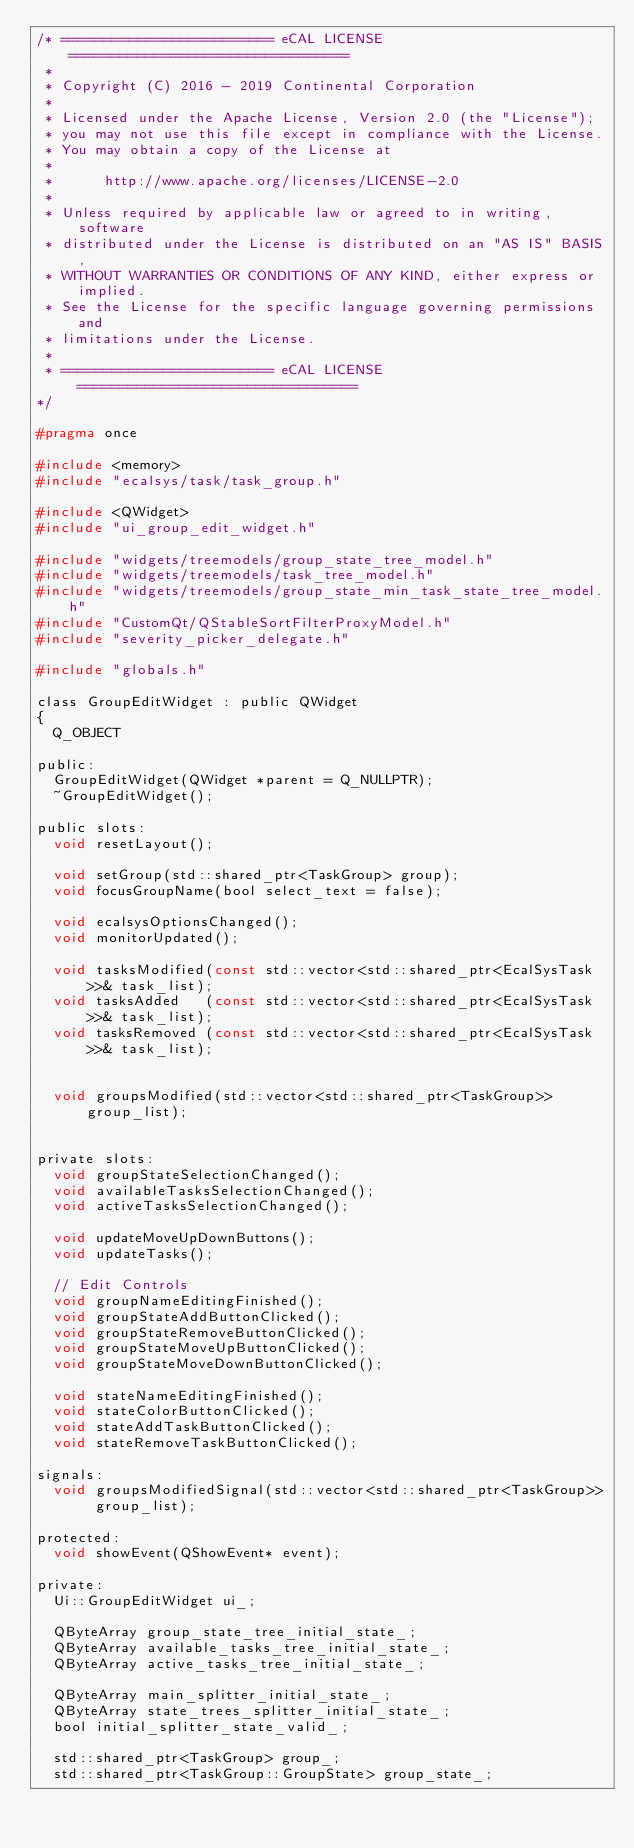Convert code to text. <code><loc_0><loc_0><loc_500><loc_500><_C_>/* ========================= eCAL LICENSE =================================
 *
 * Copyright (C) 2016 - 2019 Continental Corporation
 *
 * Licensed under the Apache License, Version 2.0 (the "License");
 * you may not use this file except in compliance with the License.
 * You may obtain a copy of the License at
 * 
 *      http://www.apache.org/licenses/LICENSE-2.0
 * 
 * Unless required by applicable law or agreed to in writing, software
 * distributed under the License is distributed on an "AS IS" BASIS,
 * WITHOUT WARRANTIES OR CONDITIONS OF ANY KIND, either express or implied.
 * See the License for the specific language governing permissions and
 * limitations under the License.
 *
 * ========================= eCAL LICENSE =================================
*/

#pragma once

#include <memory>
#include "ecalsys/task/task_group.h"

#include <QWidget>
#include "ui_group_edit_widget.h"

#include "widgets/treemodels/group_state_tree_model.h"
#include "widgets/treemodels/task_tree_model.h"
#include "widgets/treemodels/group_state_min_task_state_tree_model.h"
#include "CustomQt/QStableSortFilterProxyModel.h"
#include "severity_picker_delegate.h"

#include "globals.h"

class GroupEditWidget : public QWidget
{
  Q_OBJECT

public:
  GroupEditWidget(QWidget *parent = Q_NULLPTR);
  ~GroupEditWidget();

public slots:
  void resetLayout();

  void setGroup(std::shared_ptr<TaskGroup> group);
  void focusGroupName(bool select_text = false);

  void ecalsysOptionsChanged();
  void monitorUpdated();

  void tasksModified(const std::vector<std::shared_ptr<EcalSysTask>>& task_list);
  void tasksAdded   (const std::vector<std::shared_ptr<EcalSysTask>>& task_list);
  void tasksRemoved (const std::vector<std::shared_ptr<EcalSysTask>>& task_list);


  void groupsModified(std::vector<std::shared_ptr<TaskGroup>> group_list);


private slots:
  void groupStateSelectionChanged();
  void availableTasksSelectionChanged();
  void activeTasksSelectionChanged();

  void updateMoveUpDownButtons();
  void updateTasks();

  // Edit Controls
  void groupNameEditingFinished();
  void groupStateAddButtonClicked();
  void groupStateRemoveButtonClicked();
  void groupStateMoveUpButtonClicked();
  void groupStateMoveDownButtonClicked();

  void stateNameEditingFinished();
  void stateColorButtonClicked();
  void stateAddTaskButtonClicked();
  void stateRemoveTaskButtonClicked();

signals:
  void groupsModifiedSignal(std::vector<std::shared_ptr<TaskGroup>> group_list);

protected:
  void showEvent(QShowEvent* event);

private:
  Ui::GroupEditWidget ui_;

  QByteArray group_state_tree_initial_state_;
  QByteArray available_tasks_tree_initial_state_;
  QByteArray active_tasks_tree_initial_state_;

  QByteArray main_splitter_initial_state_;
  QByteArray state_trees_splitter_initial_state_;
  bool initial_splitter_state_valid_;

  std::shared_ptr<TaskGroup> group_;
  std::shared_ptr<TaskGroup::GroupState> group_state_;
</code> 